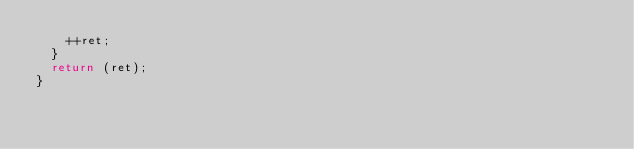Convert code to text. <code><loc_0><loc_0><loc_500><loc_500><_C_>		++ret;
	}
	return (ret);
}
</code> 